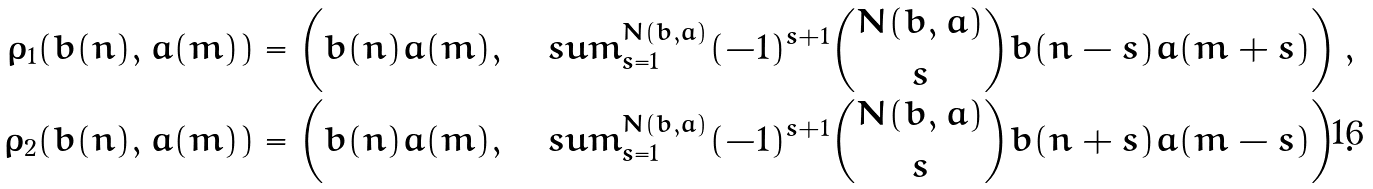<formula> <loc_0><loc_0><loc_500><loc_500>\rho _ { 1 } ( b ( n ) , a ( m ) ) = \left ( b ( n ) a ( m ) , \ \ \ s u m _ { s = 1 } ^ { N ( b , a ) } ( - 1 ) ^ { s + 1 } \binom { N ( b , a ) } { s } b ( n - s ) a ( m + s ) \right ) , \\ \rho _ { 2 } ( b ( n ) , a ( m ) ) = \left ( b ( n ) a ( m ) , \ \ \ s u m _ { s = 1 } ^ { N ( b , a ) } ( - 1 ) ^ { s + 1 } \binom { N ( b , a ) } { s } b ( n + s ) a ( m - s ) \right ) .</formula> 